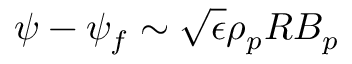<formula> <loc_0><loc_0><loc_500><loc_500>\psi - \psi _ { f } \sim \sqrt { \epsilon } \rho _ { p } R B _ { p }</formula> 